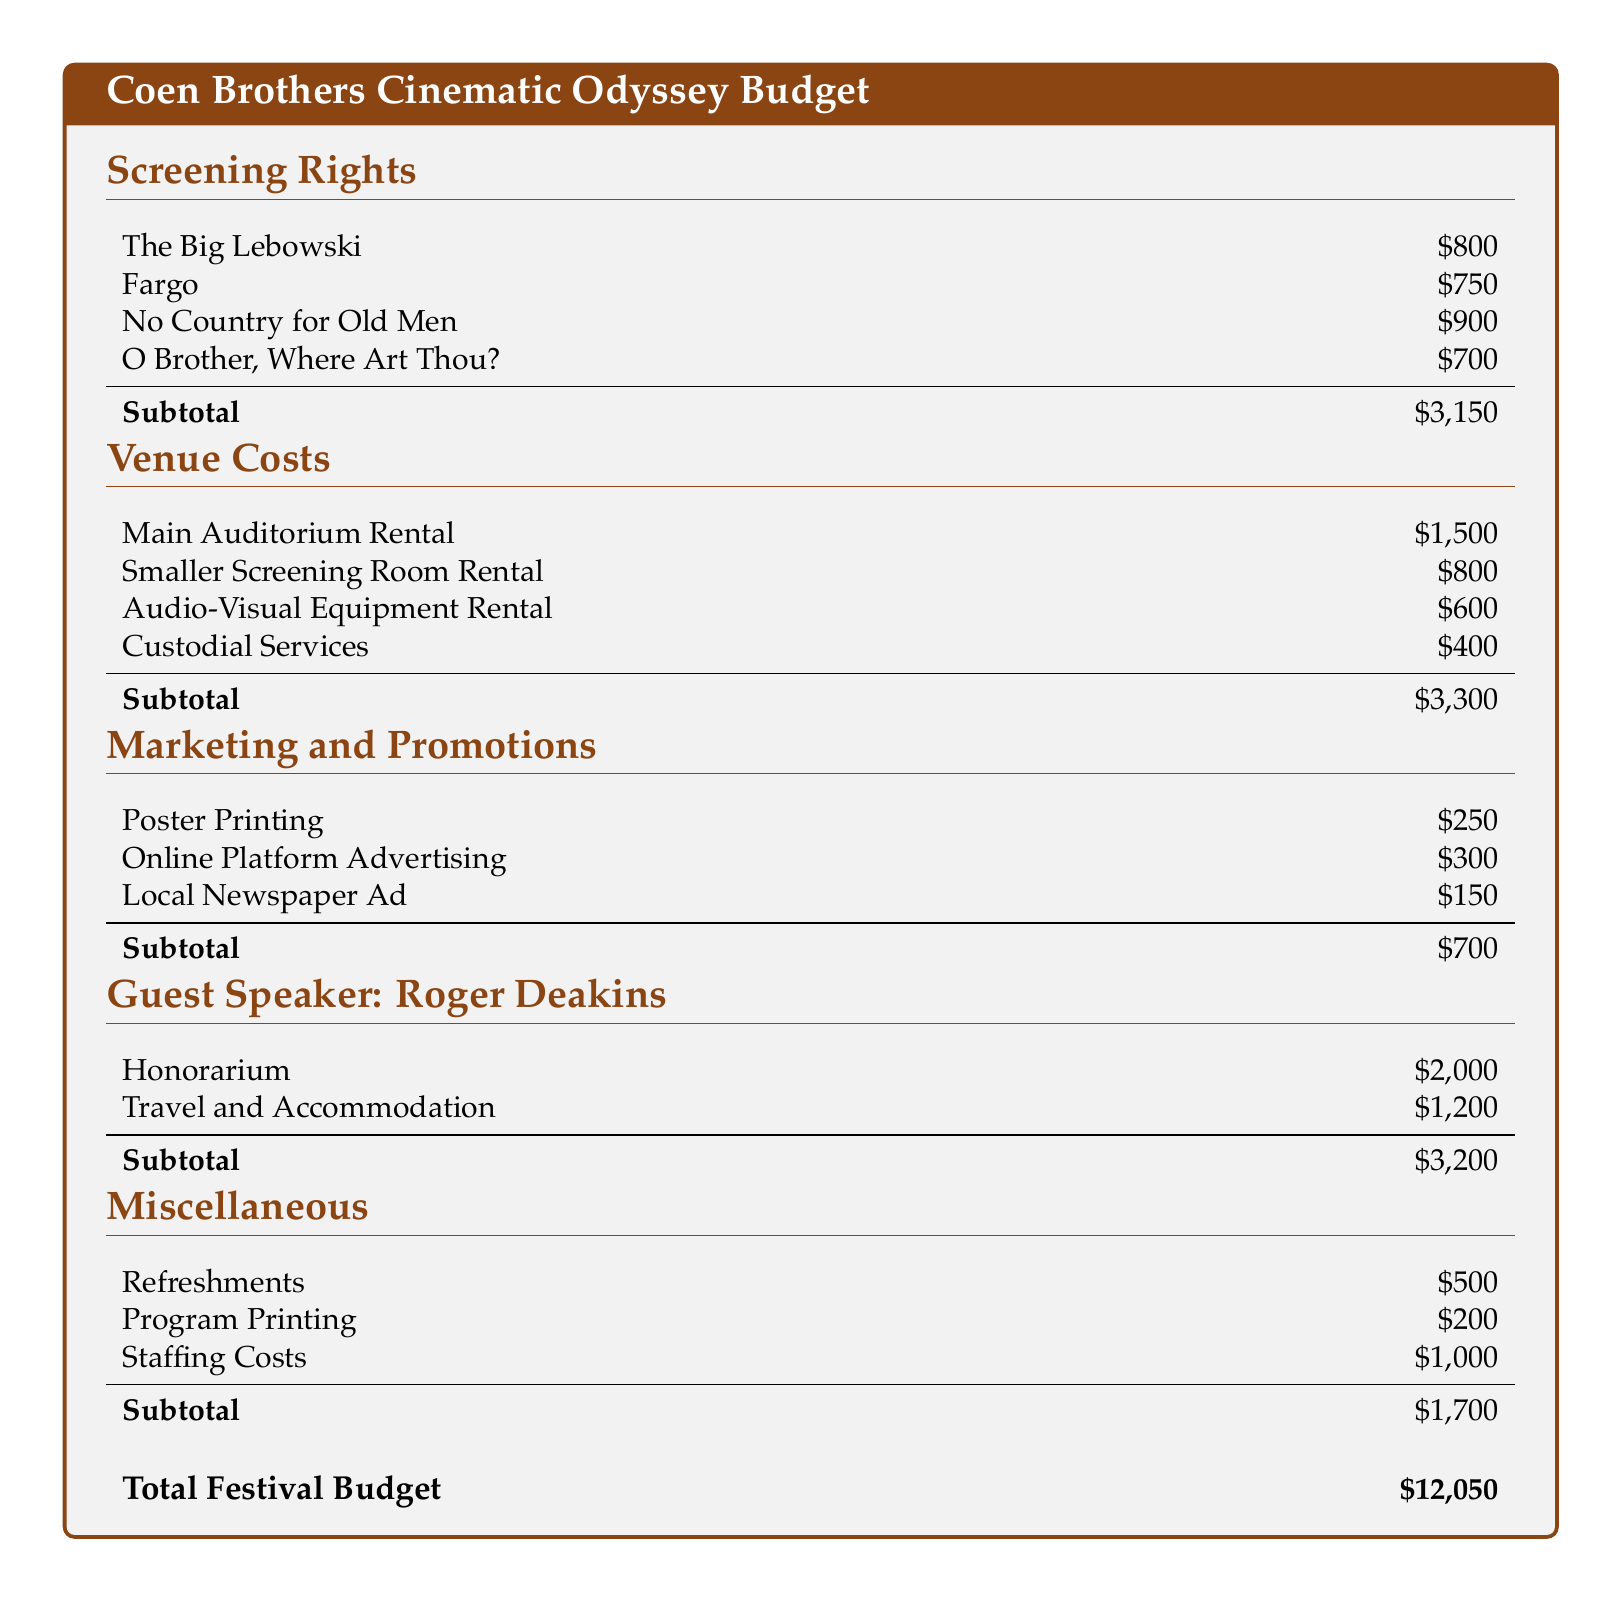What is the screening right cost for Fargo? The document lists the screening right cost for Fargo as \$750.
Answer: \$750 What is the subtotal for screening rights? The subtotal for screening rights is the total of the individual screening right costs, which is \$3,150.
Answer: \$3,150 What is the cost of renting the Main Auditorium? The cost for renting the Main Auditorium is specified in the venue costs section as \$1,500.
Answer: \$1,500 What is the total budget for the festival? The total budget is presented at the end of the document as the sum of all categories, amounting to \$12,050.
Answer: \$12,050 How much is allocated for guest speaker travel and accommodation? The document states that the travel and accommodation for the guest speaker is \$1,200.
Answer: \$1,200 What is the total cost of marketing and promotions? The subtotal for marketing and promotions is calculated as \$700 as listed in the respective section.
Answer: \$700 What is the honorarium for the guest speaker? The document specifies that the honorarium for Roger Deakins is \$2,000.
Answer: \$2,000 How much is budgeted for custodial services? The cost for custodial services is indicated as \$400 in the venue costs section.
Answer: \$400 What is included in miscellaneous costs? The miscellaneous costs include refreshments, program printing, and staffing costs totaling \$1,700.
Answer: \$1,700 